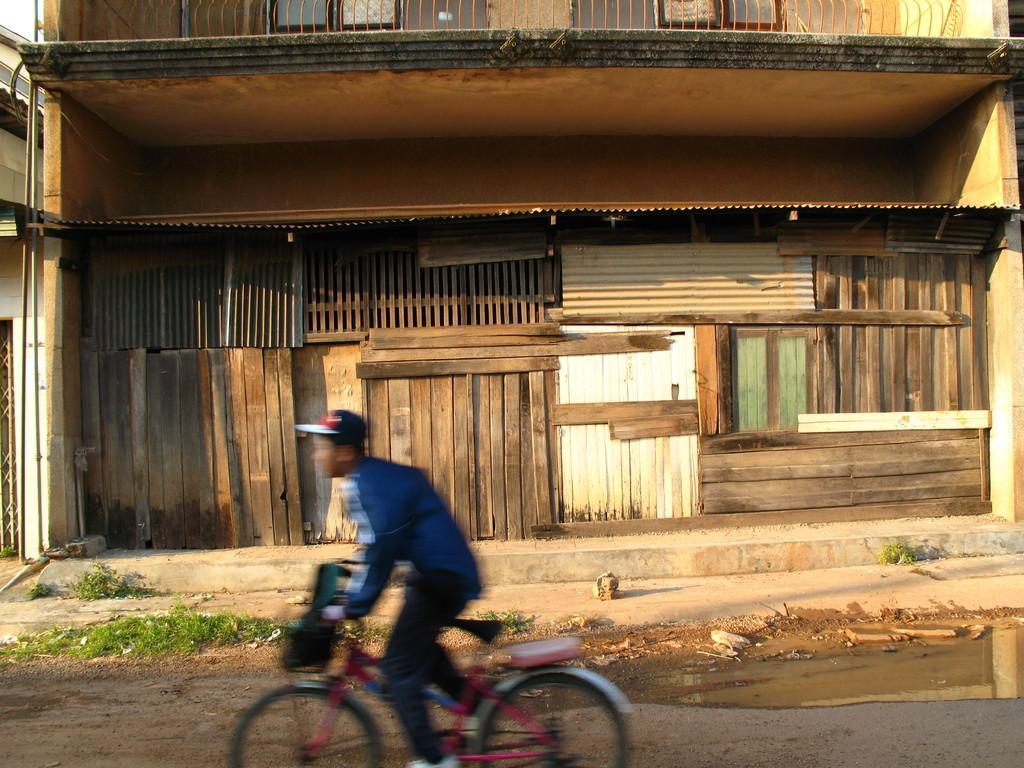Could you give a brief overview of what you see in this image? This image is taken outdoors. At the bottom of the image there is a road. In the middle of the image a boy is riding on the bicycle. In the background there is a building with walls, windows, railings and wooden sticks. There is grass on the ground. 